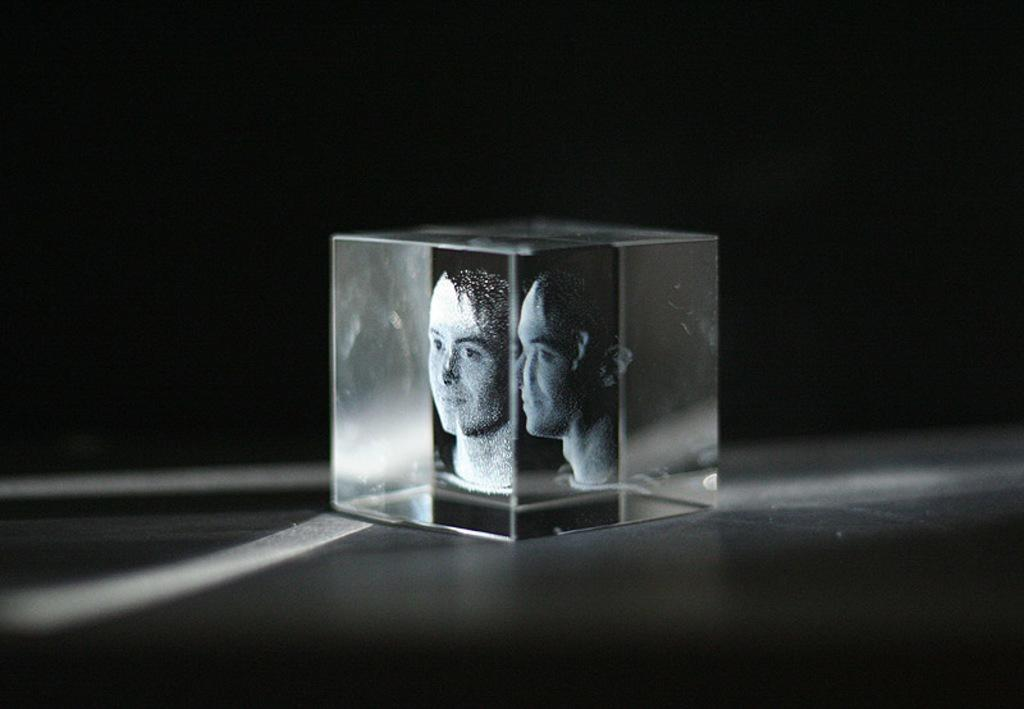What is depicted on the glass box in the image? There are persons' faces on a glass box in the image. Where is the glass box located? The glass box is on a platform. What can be observed about the background of the image? The background of the image is dark. How many letters are visible on the glass box in the image? There are no letters visible on the glass box in the image; only faces are depicted. What type of light source is illuminating the persons' faces on the glass box? There is no information about a light source in the image; the focus is on the faces and the glass box. 